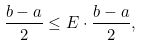Convert formula to latex. <formula><loc_0><loc_0><loc_500><loc_500>\frac { b - a } { 2 } \leq E \cdot \frac { b - a } { 2 } ,</formula> 